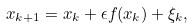Convert formula to latex. <formula><loc_0><loc_0><loc_500><loc_500>x _ { k + 1 } = x _ { k } + \epsilon f ( x _ { k } ) + \xi _ { k } ,</formula> 